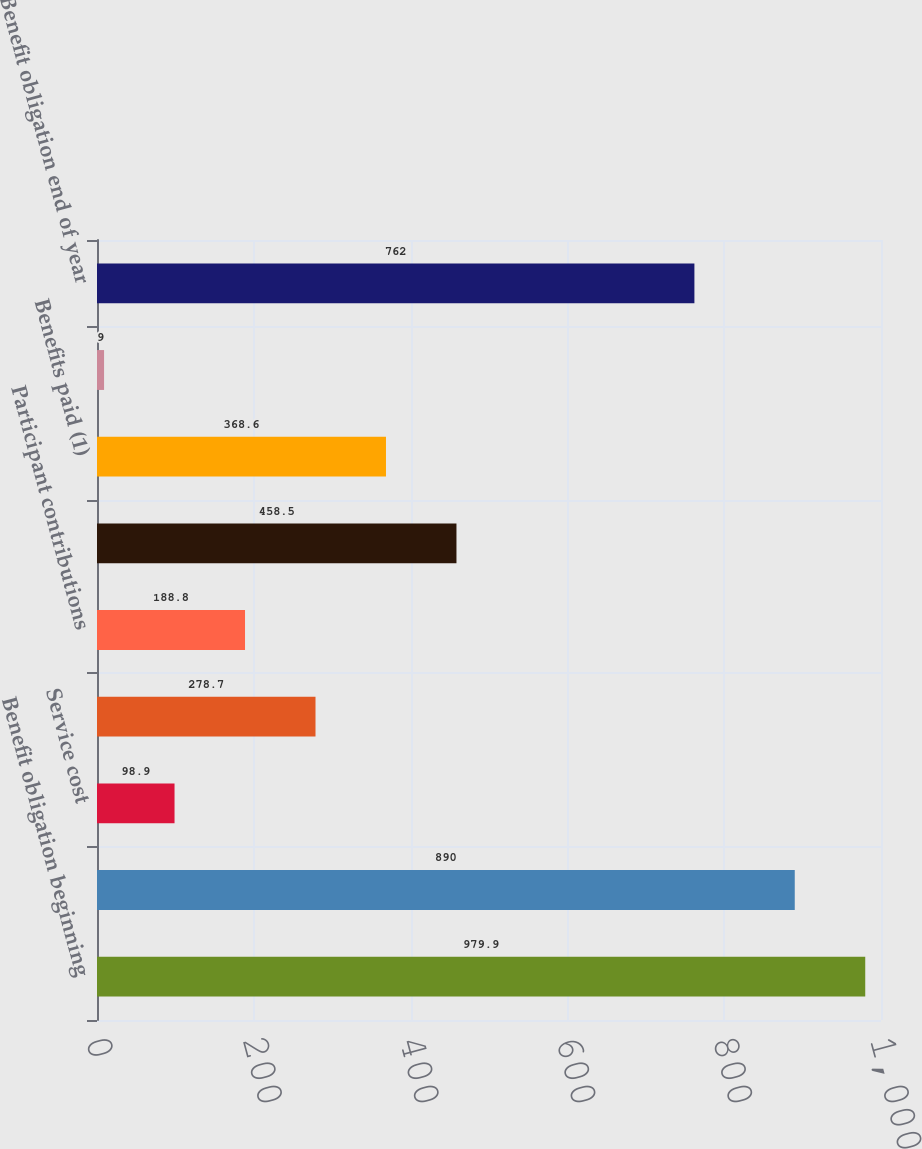Convert chart to OTSL. <chart><loc_0><loc_0><loc_500><loc_500><bar_chart><fcel>Benefit obligation beginning<fcel>Benefit obligation<fcel>Service cost<fcel>Interest cost<fcel>Participant contributions<fcel>Actuarial loss (gain)<fcel>Benefits paid (1)<fcel>Translation adjustment and<fcel>Benefit obligation end of year<nl><fcel>979.9<fcel>890<fcel>98.9<fcel>278.7<fcel>188.8<fcel>458.5<fcel>368.6<fcel>9<fcel>762<nl></chart> 